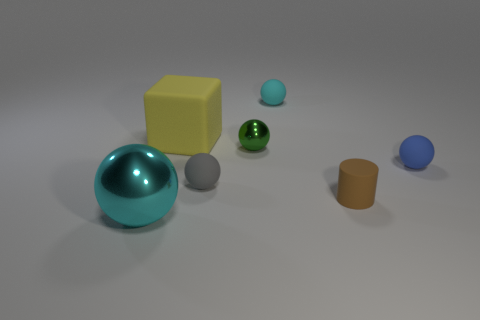Subtract all green spheres. How many spheres are left? 4 Subtract all blue balls. How many balls are left? 4 Subtract all brown balls. Subtract all brown cubes. How many balls are left? 5 Add 2 yellow cubes. How many objects exist? 9 Subtract all cubes. How many objects are left? 6 Subtract 0 blue blocks. How many objects are left? 7 Subtract all cyan balls. Subtract all matte things. How many objects are left? 0 Add 1 large cubes. How many large cubes are left? 2 Add 7 tiny blue balls. How many tiny blue balls exist? 8 